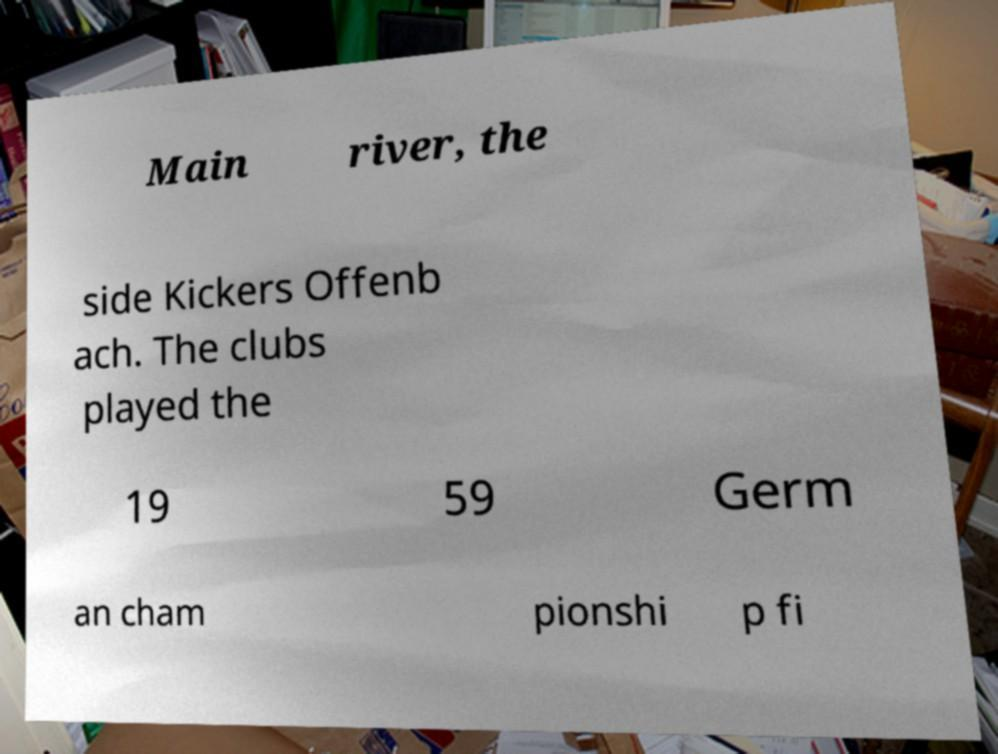Can you read and provide the text displayed in the image?This photo seems to have some interesting text. Can you extract and type it out for me? Main river, the side Kickers Offenb ach. The clubs played the 19 59 Germ an cham pionshi p fi 